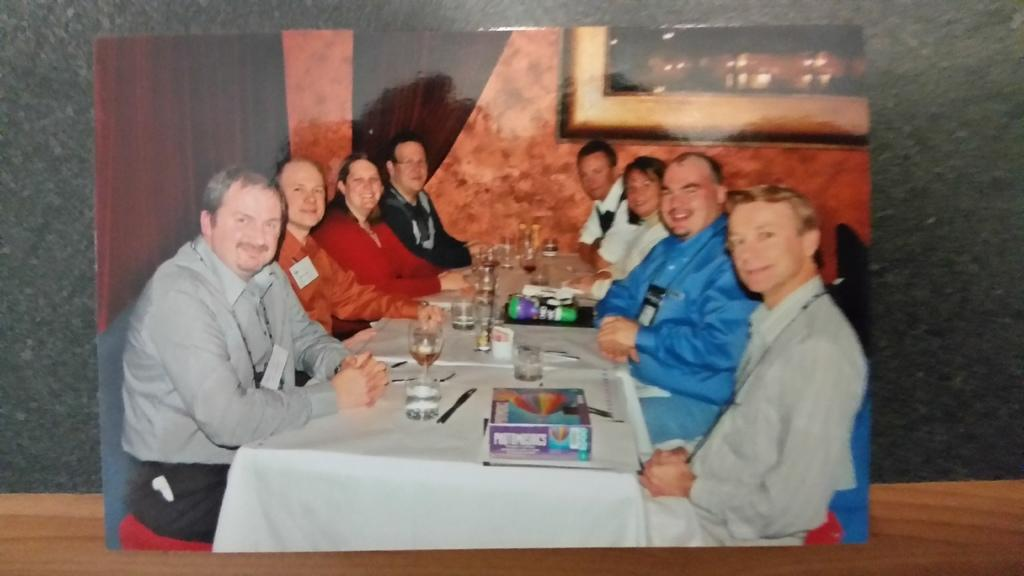What are the people in the image doing? The people in the image are sitting. Where are the people sitting in relation to the table? The people are sitting in front of the table. What can be observed about the table in the image? There are many items on the table. What type of skirt is the servant wearing in the image? There is no servant or skirt present in the image. What is the yak doing in the image? There is no yak present in the image. 